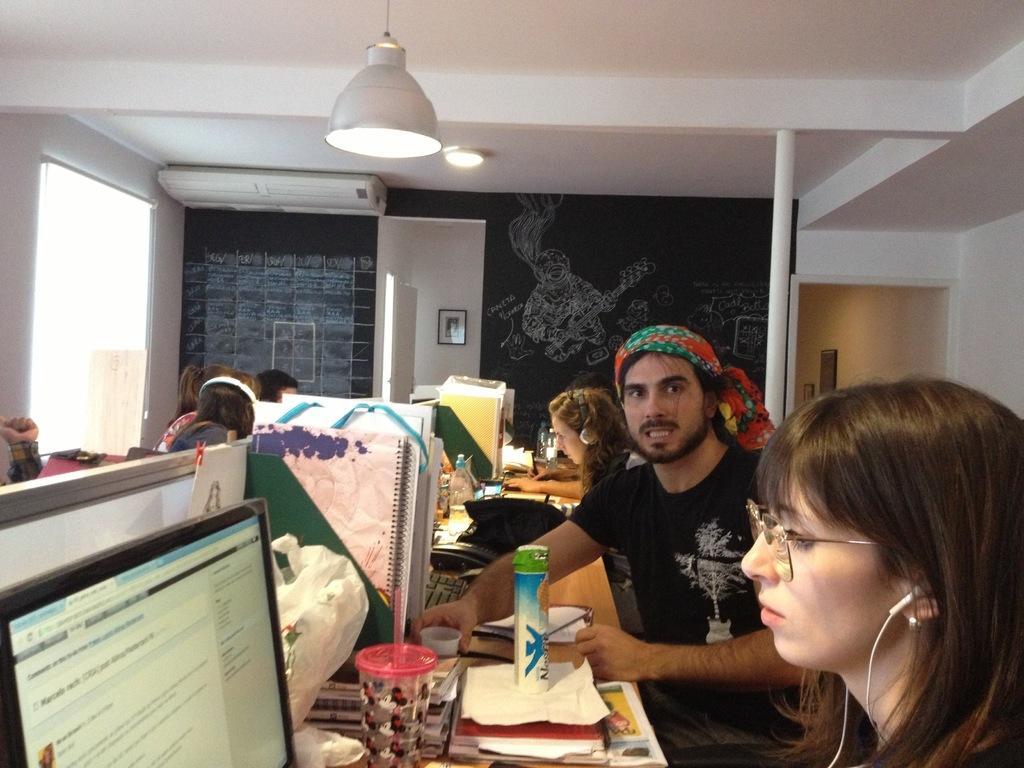How would you summarize this image in a sentence or two? At the top we can see ceiling and lights. This is air conditioner. Here we can see blackboard something written and drawn on it. Here we can see frame over a wall. We can see all the persons sitting on chairs in front of a table and on the table we can see books, bottles, monitors, papers. This is a window. 